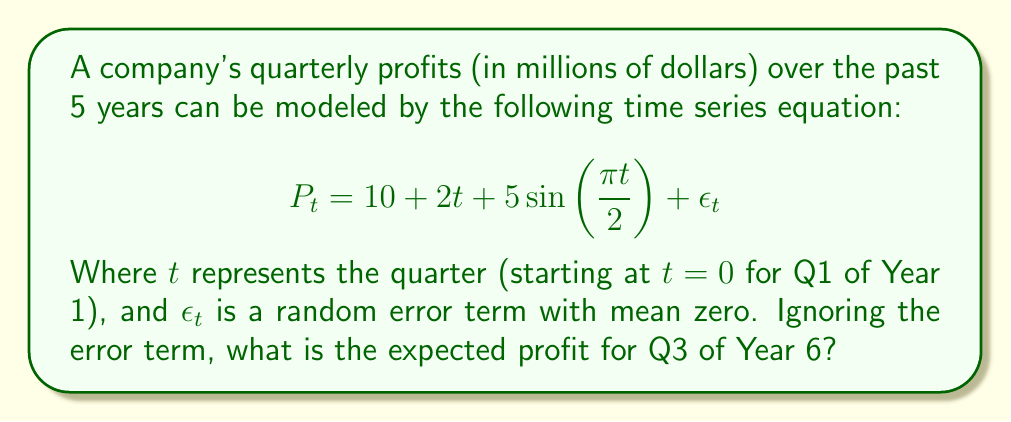Can you solve this math problem? To solve this problem, we need to follow these steps:

1. Identify the components of the time series equation:
   - Constant term: $10
   - Linear trend: $2t$
   - Cyclical component: $5\sin(\frac{\pi t}{2})$

2. Determine the value of $t$ for Q3 of Year 6:
   - Each year has 4 quarters
   - 5 full years have passed: $5 \times 4 = 20$ quarters
   - Q3 is the 3rd quarter of the 6th year, so we add 2 more quarters
   - Thus, $t = 20 + 2 = 22$

3. Substitute $t = 22$ into the equation (ignoring the error term):

   $$P_{22} = 10 + 2(22) + 5\sin(\frac{\pi (22)}{2})$$

4. Calculate each component:
   - Constant: $10$
   - Linear trend: $2(22) = 44$
   - Cyclical component: $5\sin(\frac{\pi (22)}{2}) = 5\sin(11\pi) = 0$
     (Note: $\sin(11\pi) = \sin(\pi) = 0$)

5. Sum up all components:
   $$P_{22} = 10 + 44 + 0 = 54$$

Therefore, the expected profit for Q3 of Year 6 is $54 million.
Answer: $54 million 